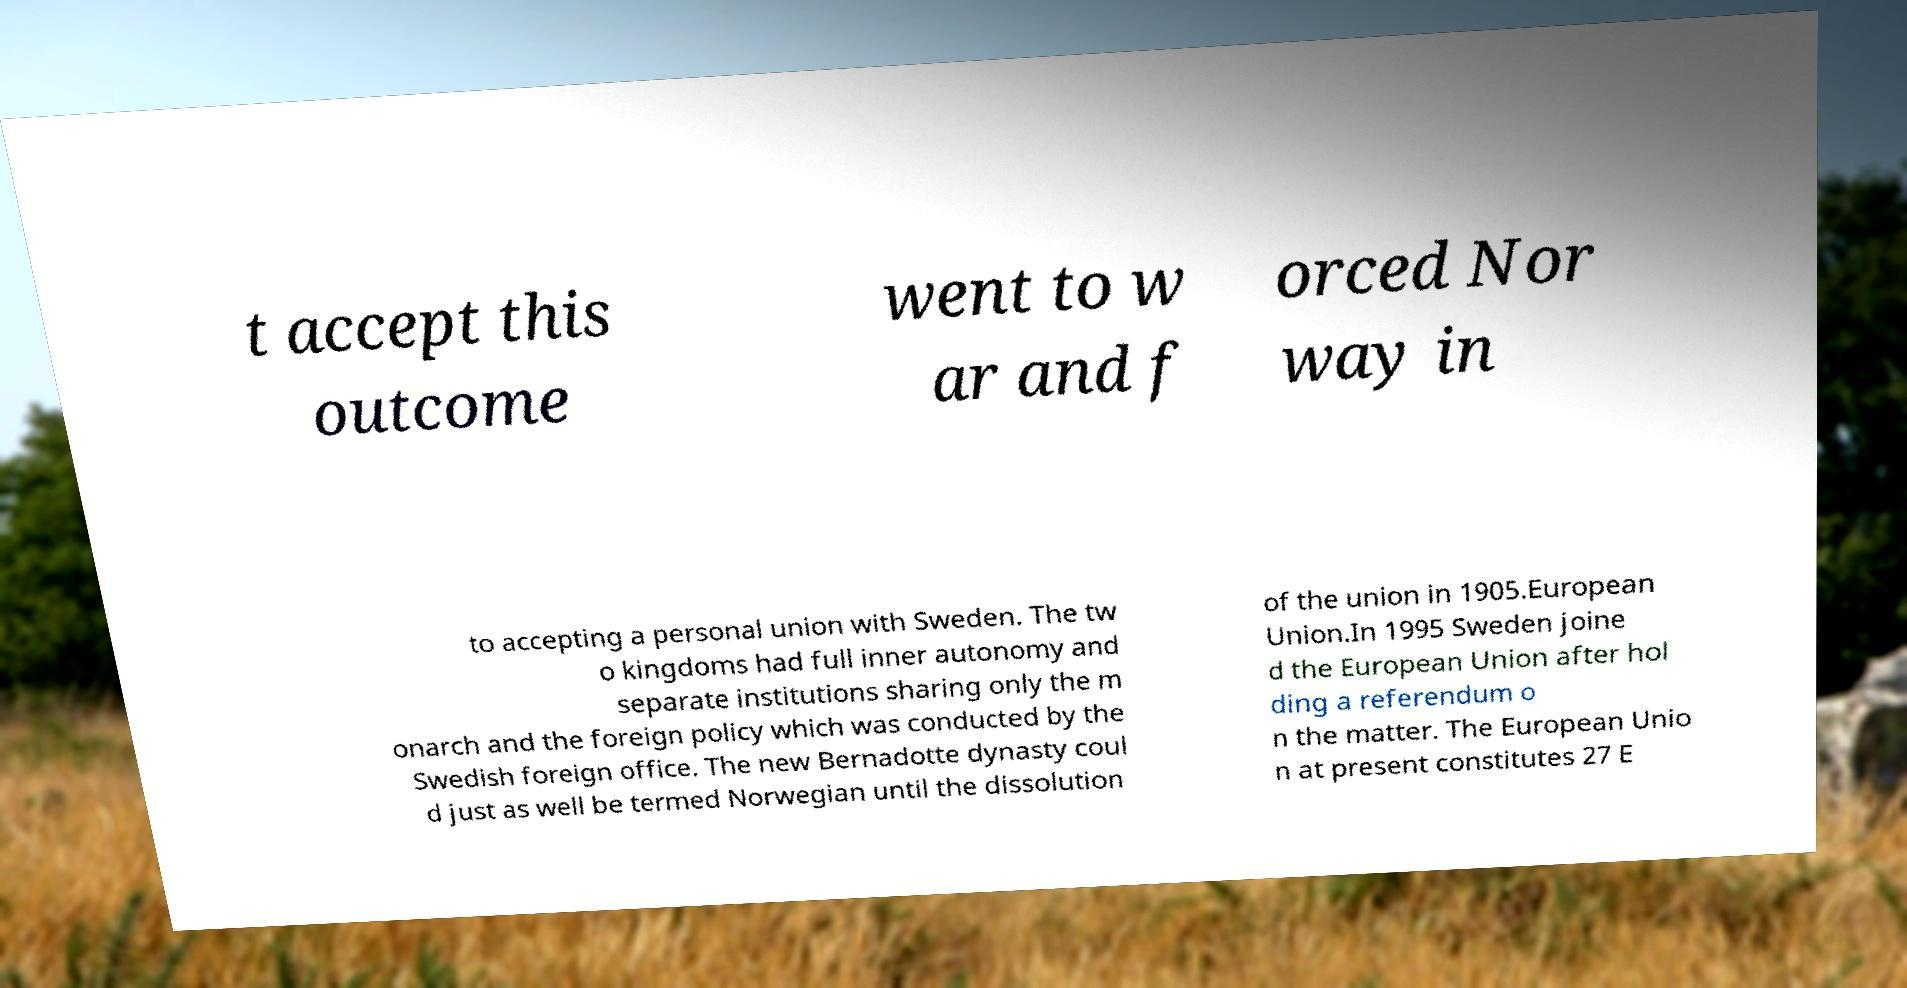Please identify and transcribe the text found in this image. t accept this outcome went to w ar and f orced Nor way in to accepting a personal union with Sweden. The tw o kingdoms had full inner autonomy and separate institutions sharing only the m onarch and the foreign policy which was conducted by the Swedish foreign office. The new Bernadotte dynasty coul d just as well be termed Norwegian until the dissolution of the union in 1905.European Union.In 1995 Sweden joine d the European Union after hol ding a referendum o n the matter. The European Unio n at present constitutes 27 E 